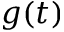<formula> <loc_0><loc_0><loc_500><loc_500>g ( t )</formula> 